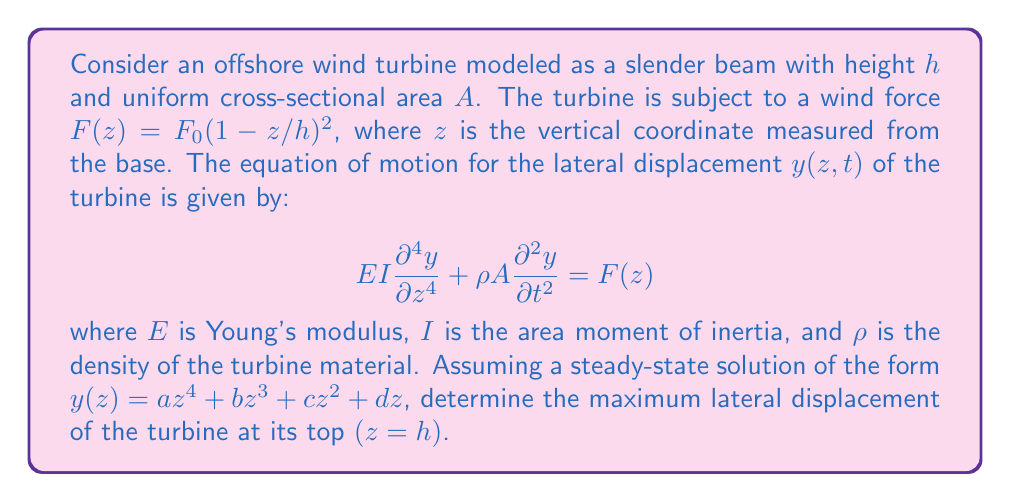Can you answer this question? To solve this problem, we'll follow these steps:

1) First, we consider the steady-state solution, which means $\frac{\partial^2y}{\partial t^2} = 0$. Our equation becomes:

   $$EI\frac{d^4y}{dz^4} = F(z) = F_0(1-z/h)^2$$

2) We integrate this equation four times:

   $$EI\frac{d^3y}{dz^3} = F_0(z - 2zh/h + z^3/3h^2) + C_1$$
   
   $$EI\frac{d^2y}{dz^2} = F_0(z^2/2 - z^2h/h + z^4/12h^2) + C_1z + C_2$$
   
   $$EI\frac{dy}{dz} = F_0(z^3/6 - z^3h/3h + z^5/60h^2) + C_1z^2/2 + C_2z + C_3$$
   
   $$EIy = F_0(z^4/24 - z^4h/12h + z^6/360h^2) + C_1z^3/6 + C_2z^2/2 + C_3z + C_4$$

3) We use the boundary conditions for a cantilever beam:
   At $z=0$: $y=0$ and $\frac{dy}{dz}=0$
   At $z=h$: $\frac{d^2y}{dz^2}=0$ and $\frac{d^3y}{dz^3}=0$

4) Applying these conditions:
   
   $C_4 = 0$
   $C_3 = 0$
   $C_1 = -F_0h/2EI$
   $C_2 = 5F_0h^2/24EI$

5) Substituting these back into our solution:

   $$y(z) = \frac{F_0}{EI}(\frac{z^4}{24} - \frac{z^4h}{12h} + \frac{z^6}{360h^2} - \frac{hz^3}{12} + \frac{5h^2z^2}{48})$$

6) To find the maximum displacement, we evaluate this at $z=h$:

   $$y(h) = \frac{F_0h^4}{EI}(\frac{1}{24} - \frac{1}{12} + \frac{1}{360} - \frac{1}{12} + \frac{5}{48})$$

7) Simplifying:

   $$y(h) = \frac{F_0h^4}{EI}(\frac{1}{120})$$
Answer: $y(h) = \frac{F_0h^4}{120EI}$ 